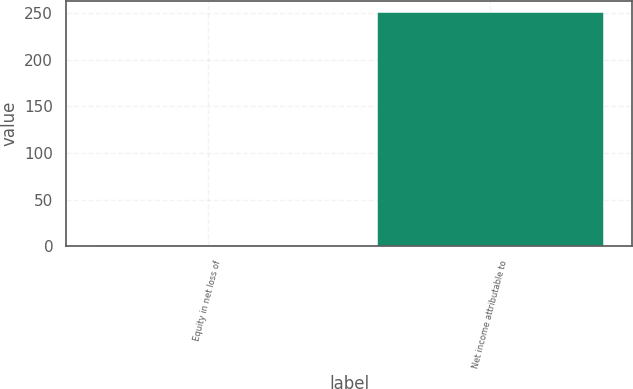Convert chart. <chart><loc_0><loc_0><loc_500><loc_500><bar_chart><fcel>Equity in net loss of<fcel>Net income attributable to<nl><fcel>1.6<fcel>251.2<nl></chart> 